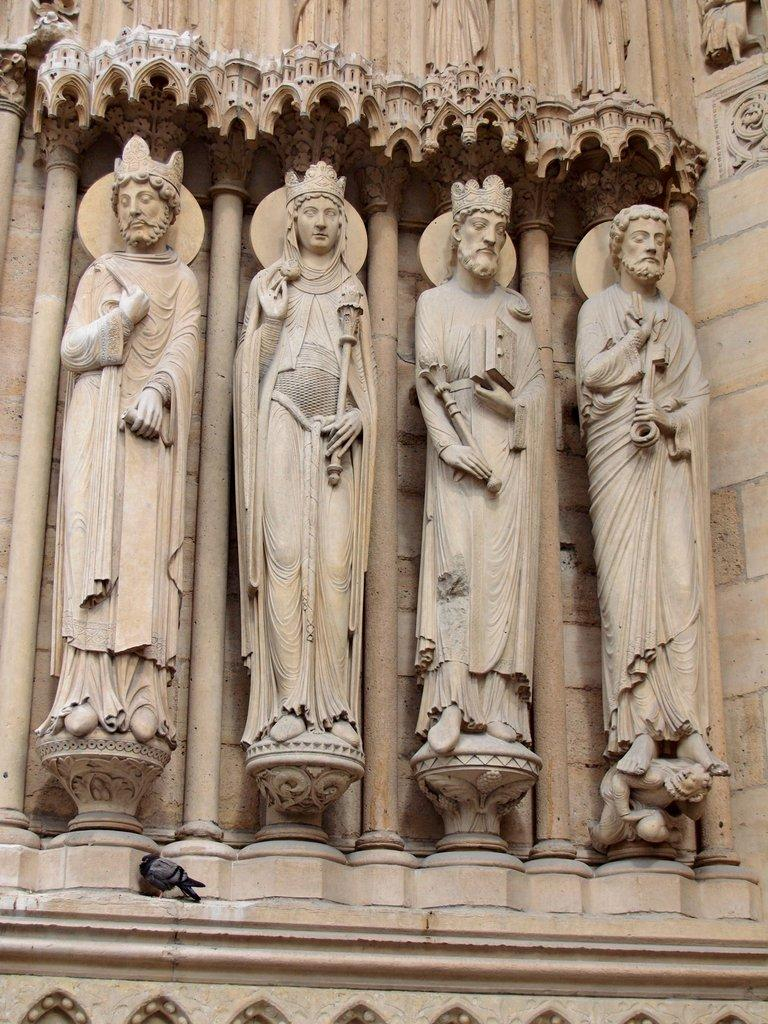What is the main subject of the image? The image is a zoomed-in view of a monument. What can be seen on the monument in the image? There are four sculptures on the wall of the monument. Are there any living creatures visible in the image? Yes, a bird is visible in the image. What type of design can be seen on the crow's feathers in the image? There is no crow present in the image, only a bird. What color is the sky in the image? The provided facts do not mention the color of the sky, and it is not visible in the image. 